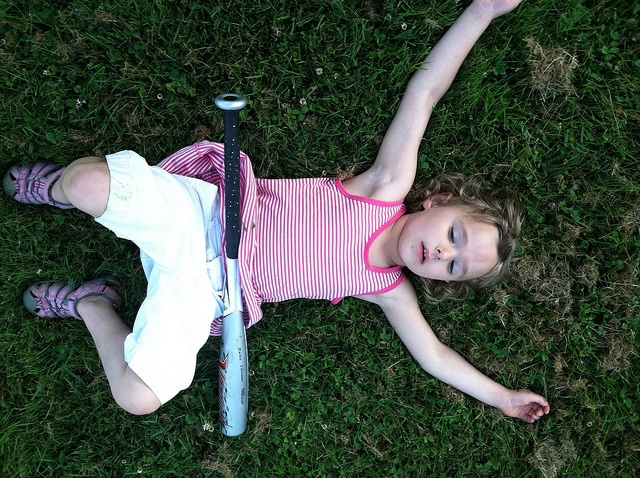Describe the objects in this image and their specific colors. I can see people in black, white, darkgray, and pink tones and baseball bat in black, lightblue, navy, and white tones in this image. 